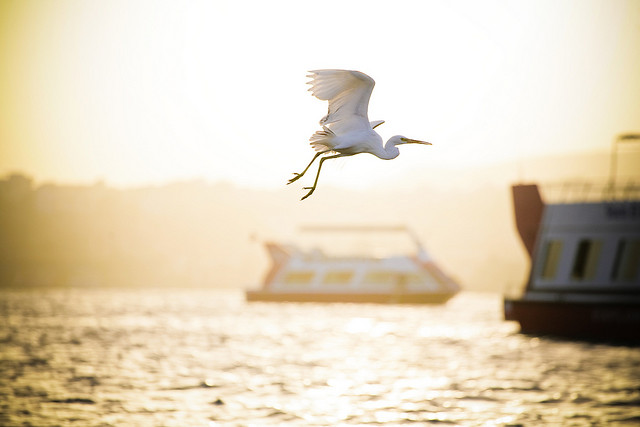Please provide a short description for this region: [0.78, 0.37, 1.0, 0.72]. This region shows the rear half of a boat on the right side. 